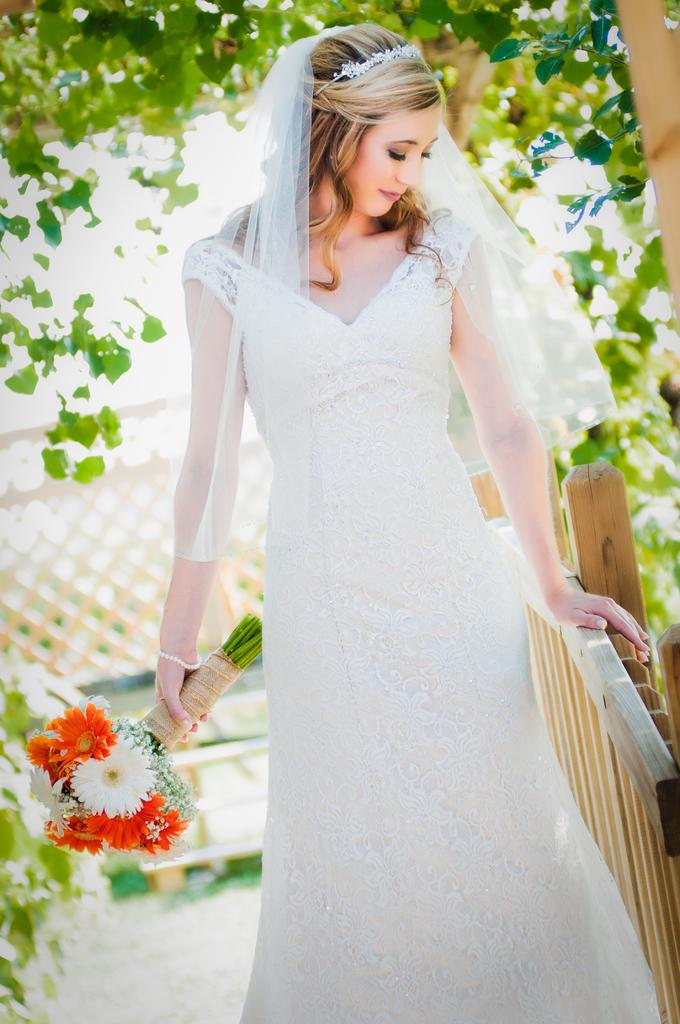Who is the main subject in the image? There is a girl in the image. What is the girl wearing? The girl is wearing a white frock. What is the girl holding in her hand? The girl is holding flowers in her hand. What can be seen on the left side of the image? There is a wooden railing and trees on the left side of the image. How would you describe the background of the image? The background of the image is blurred. What type of soup is being served in the image? There is no soup present in the image; it features a girl holding flowers. How many ants can be seen crawling on the girl's frock in the image? There are no ants visible on the girl's frock in the image. 